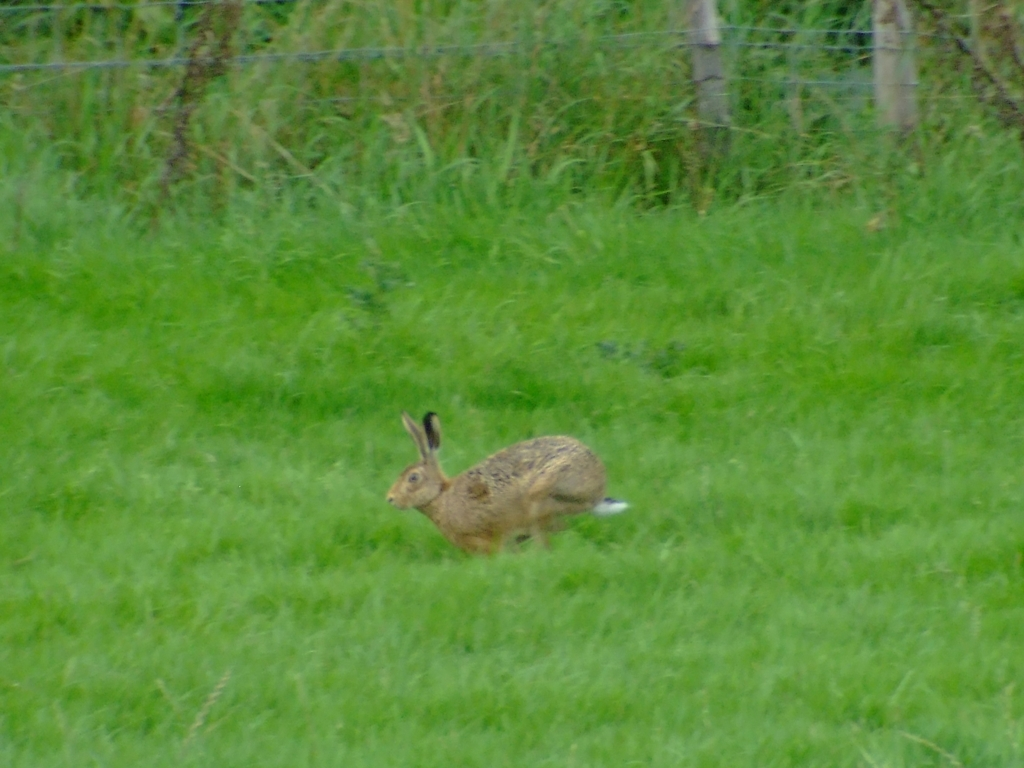What can we infer about the camera's settings based on the quality of this photo? Based on the level of noise and blurriness, it's likely that the camera's settings were adjusted for a fast-moving subject perhaps with a high ISO setting and a slower shutter speed. This would allow the camera to capture more light and attempt to freeze the motion, but at the cost of image clarity and introducing noise. Could the weather have affected the quality of the image? It's certainly possible. Overcast or dim conditions often necessitate adjustments in camera settings that can increase noise, as mentioned earlier. Additionally, if the weather was indeed overcast, the diffused lighting could contribute to the lack of sharpness and vibrancy in the colors. 